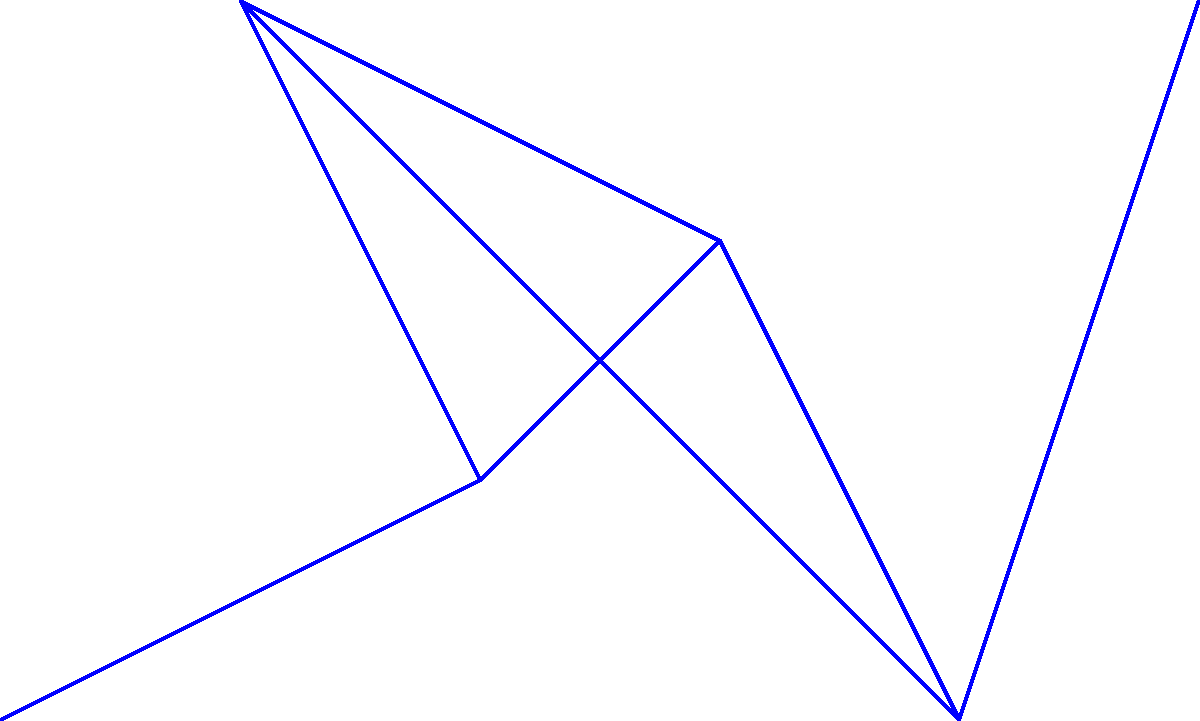In designing a flying disc course, you want to connect 6 tee pads ($T_1$ to $T_6$) with the minimum amount of pathway. The distances between tee pads are shown in the graph. What is the total length of the minimum spanning tree that connects all tee pads? To find the minimum spanning tree (MST) that connects all tee pads with the least total distance, we can use Kruskal's algorithm:

1. Sort all edges by weight in ascending order:
   (T2-T4): 2
   (T3-T4): 3
   (T2-T3): 4
   (T1-T2): 5
   (T4-T5): 6
   (T5-T6): 7
   (T3-T5): 8

2. Add edges to the MST, skipping those that would create a cycle:
   - Add (T2-T4): 2
   - Add (T3-T4): 3
   - Add (T2-T3): 4
   - Add (T1-T2): 5
   - Add (T5-T6): 7

3. The MST is complete with 5 edges (n-1 edges for n vertices).

4. Sum the weights of the selected edges:
   $2 + 3 + 4 + 5 + 7 = 21$

Therefore, the total length of the minimum spanning tree is 21 units.
Answer: 21 